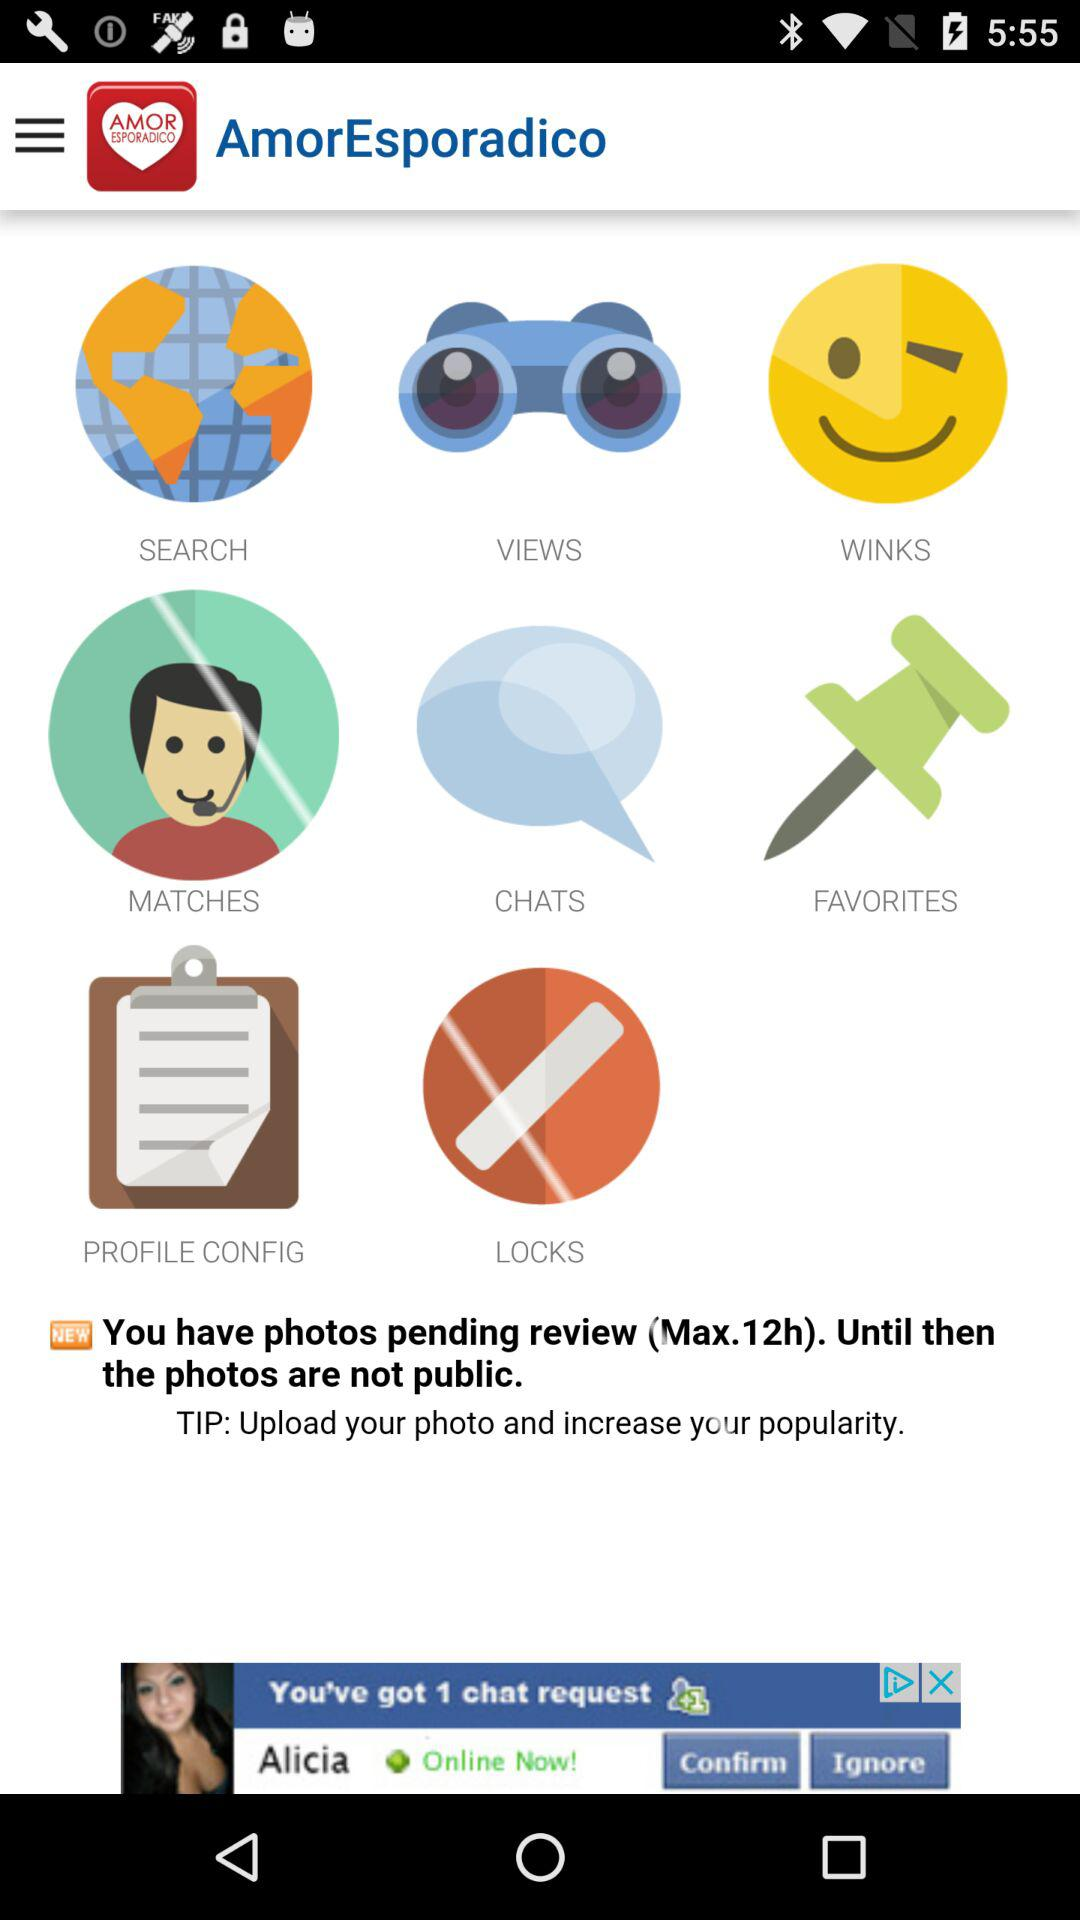What is the name of the application? The name of the application is "AmorEsporadico". 